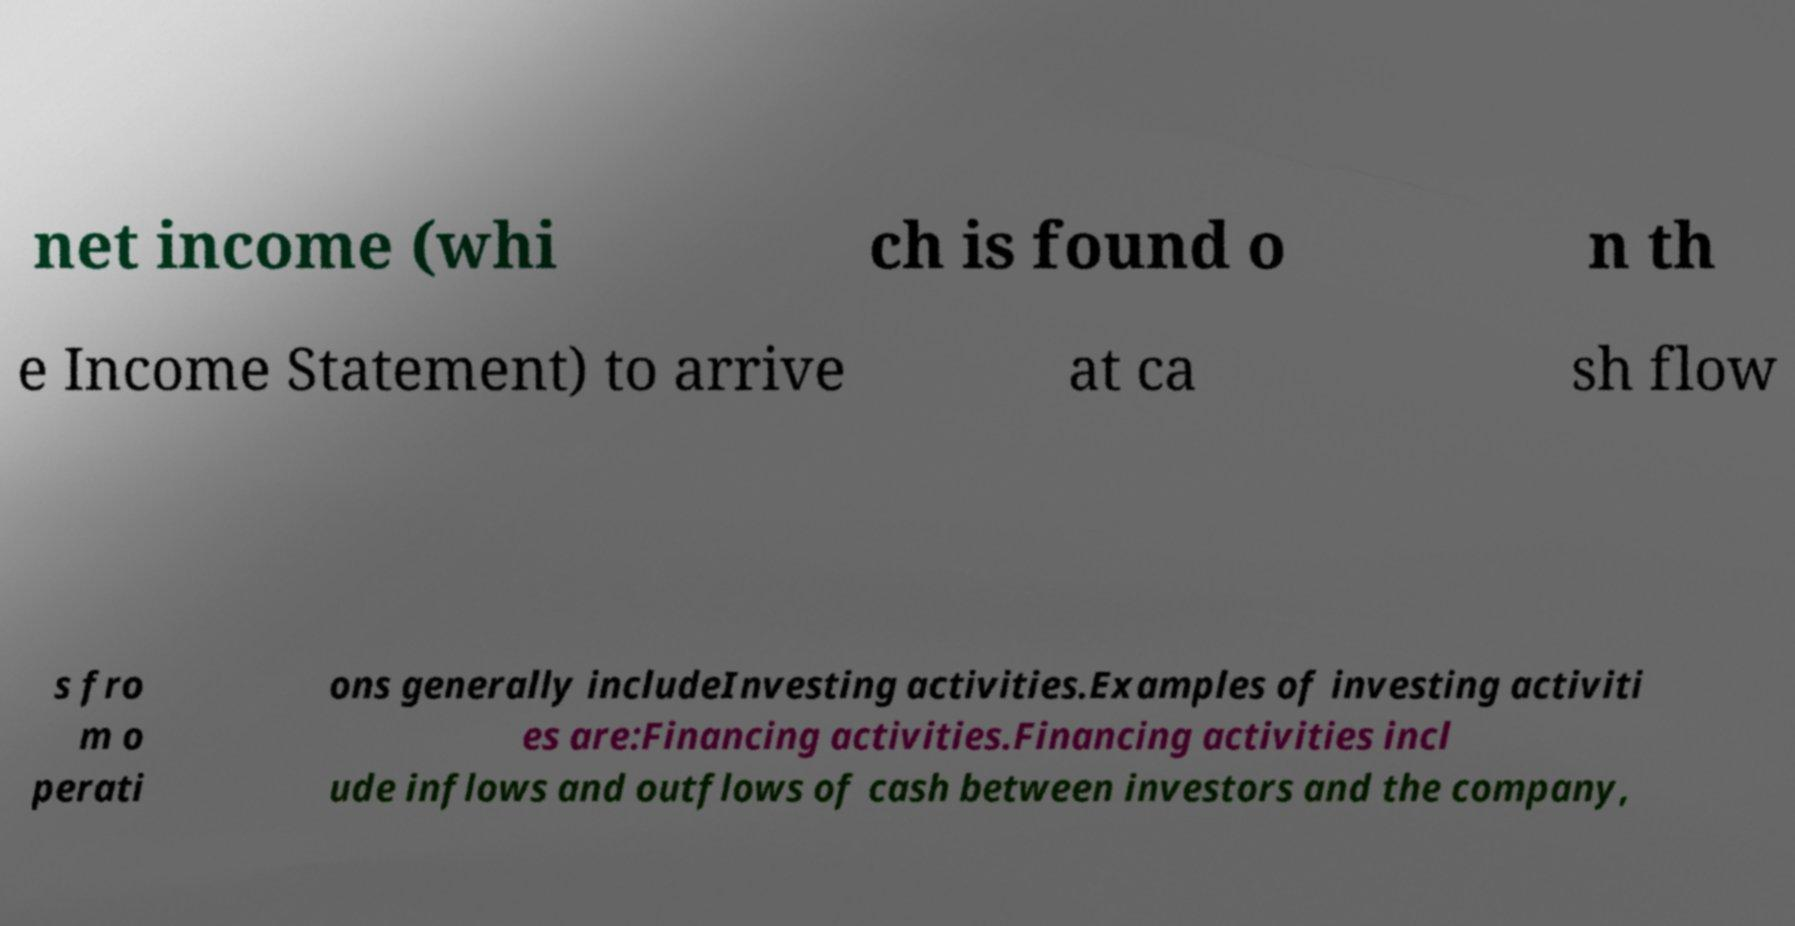Can you accurately transcribe the text from the provided image for me? net income (whi ch is found o n th e Income Statement) to arrive at ca sh flow s fro m o perati ons generally includeInvesting activities.Examples of investing activiti es are:Financing activities.Financing activities incl ude inflows and outflows of cash between investors and the company, 